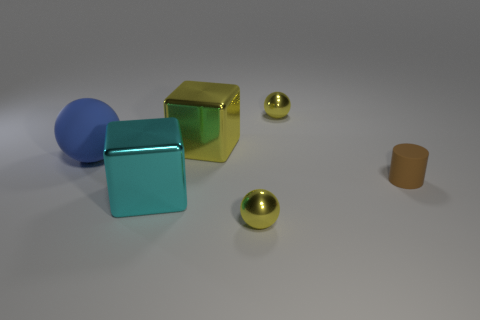There is another shiny thing that is the same shape as the large cyan metal object; what is its color?
Offer a terse response. Yellow. Are there any other things that are the same shape as the big yellow shiny object?
Provide a succinct answer. Yes. There is another cube that is made of the same material as the cyan block; what is its color?
Ensure brevity in your answer.  Yellow. There is a small yellow shiny thing behind the tiny shiny sphere in front of the big yellow object; are there any blue rubber balls on the left side of it?
Your response must be concise. Yes. Are there fewer yellow metal things left of the large cyan shiny cube than small yellow spheres behind the big yellow block?
Make the answer very short. Yes. How many tiny brown objects have the same material as the cyan thing?
Ensure brevity in your answer.  0. Is the size of the yellow metallic block the same as the yellow thing behind the large yellow shiny thing?
Give a very brief answer. No. There is a yellow sphere behind the rubber object left of the yellow sphere behind the large yellow shiny thing; what is its size?
Make the answer very short. Small. Is the number of large objects in front of the tiny cylinder greater than the number of yellow things in front of the blue matte sphere?
Your answer should be compact. No. There is a large metal block that is behind the brown object; how many large things are on the left side of it?
Keep it short and to the point. 2. 